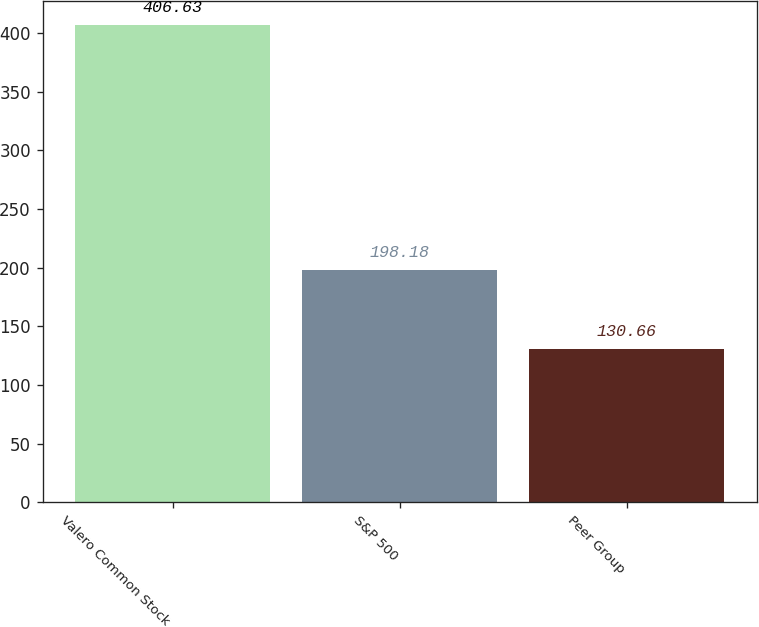Convert chart. <chart><loc_0><loc_0><loc_500><loc_500><bar_chart><fcel>Valero Common Stock<fcel>S&P 500<fcel>Peer Group<nl><fcel>406.63<fcel>198.18<fcel>130.66<nl></chart> 